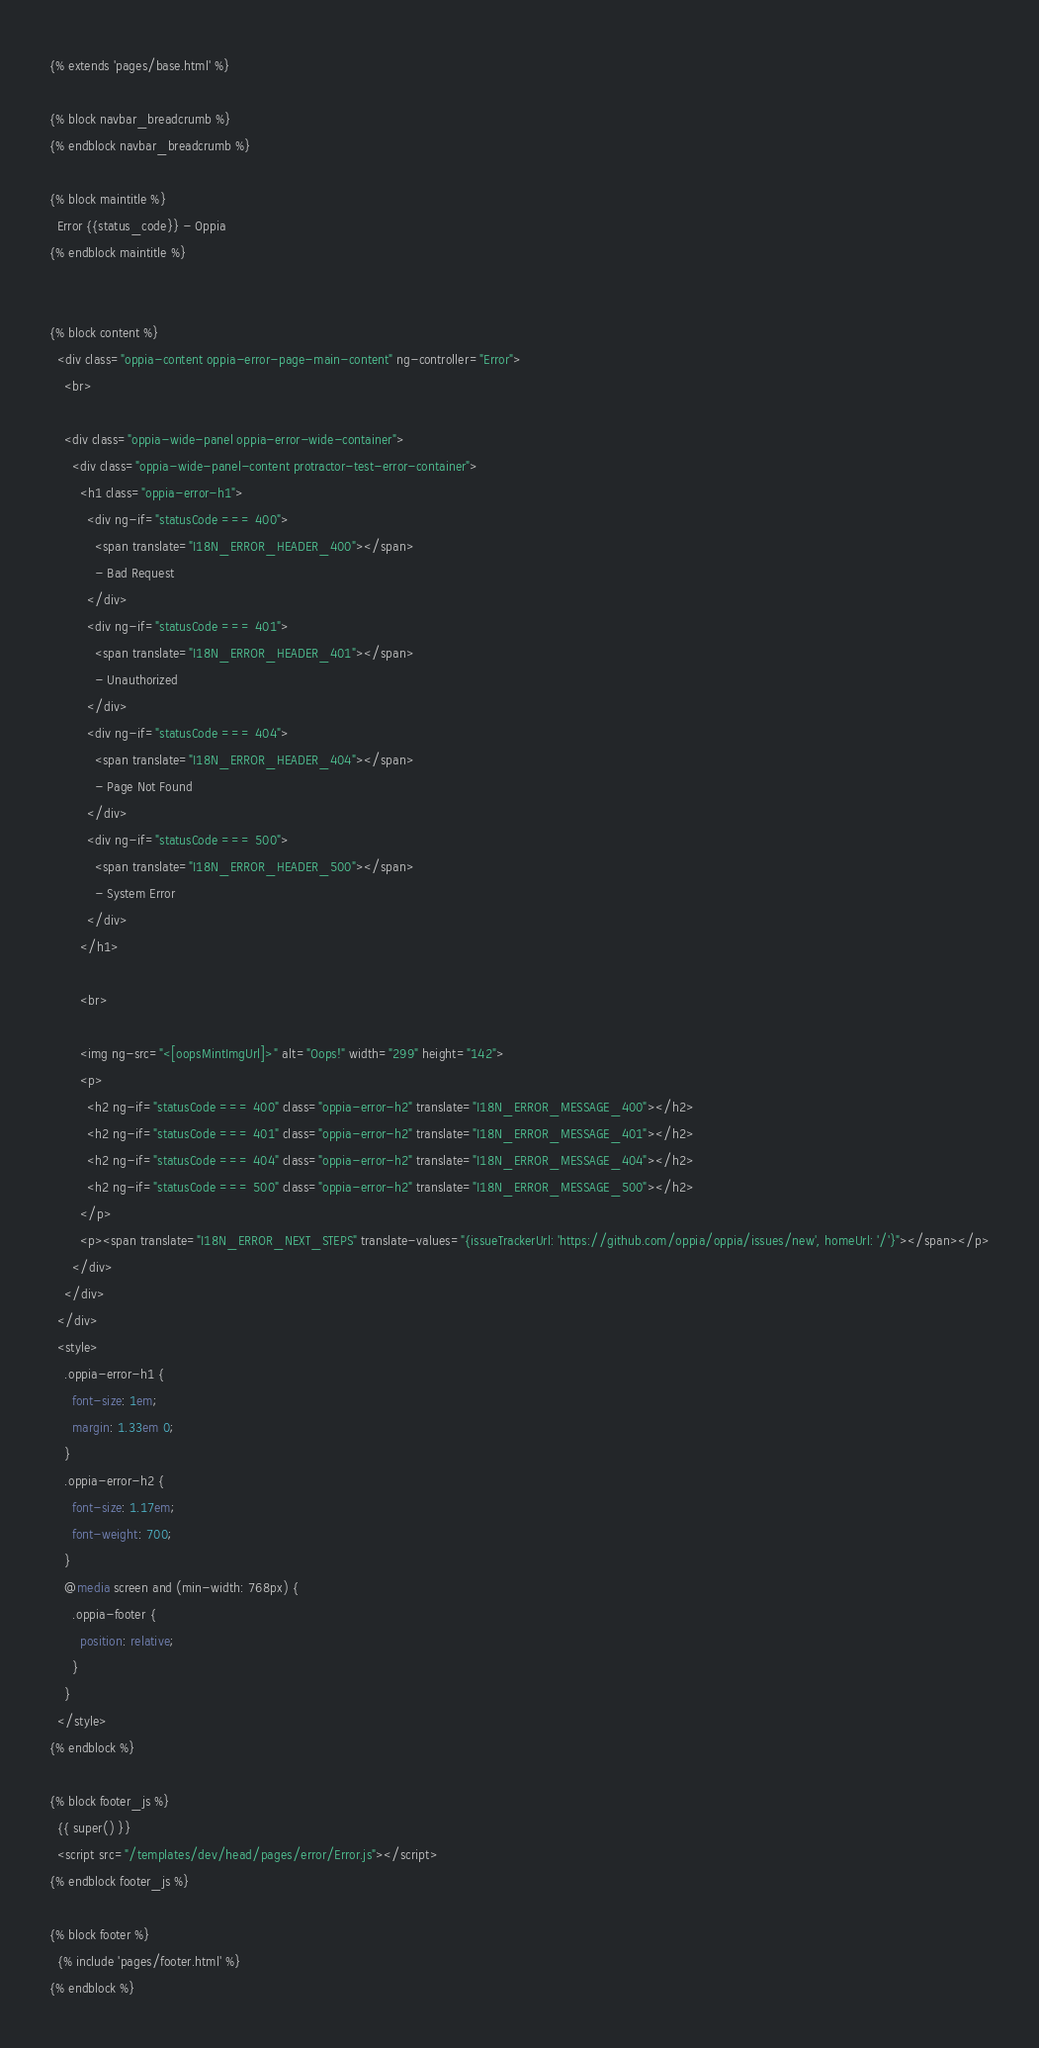<code> <loc_0><loc_0><loc_500><loc_500><_HTML_>{% extends 'pages/base.html' %}

{% block navbar_breadcrumb %}
{% endblock navbar_breadcrumb %}

{% block maintitle %}
  Error {{status_code}} - Oppia
{% endblock maintitle %}


{% block content %}
  <div class="oppia-content oppia-error-page-main-content" ng-controller="Error">
    <br>

    <div class="oppia-wide-panel oppia-error-wide-container">
      <div class="oppia-wide-panel-content protractor-test-error-container">
        <h1 class="oppia-error-h1">
          <div ng-if="statusCode === 400">
            <span translate="I18N_ERROR_HEADER_400"></span>
            - Bad Request
          </div>
          <div ng-if="statusCode === 401">
            <span translate="I18N_ERROR_HEADER_401"></span>
            - Unauthorized
          </div>
          <div ng-if="statusCode === 404">
            <span translate="I18N_ERROR_HEADER_404"></span>
            - Page Not Found
          </div>
          <div ng-if="statusCode === 500">
            <span translate="I18N_ERROR_HEADER_500"></span>
            - System Error
          </div>
        </h1>

        <br>

        <img ng-src="<[oopsMintImgUrl]>" alt="Oops!" width="299" height="142">
        <p>
          <h2 ng-if="statusCode === 400" class="oppia-error-h2" translate="I18N_ERROR_MESSAGE_400"></h2>
          <h2 ng-if="statusCode === 401" class="oppia-error-h2" translate="I18N_ERROR_MESSAGE_401"></h2>
          <h2 ng-if="statusCode === 404" class="oppia-error-h2" translate="I18N_ERROR_MESSAGE_404"></h2>
          <h2 ng-if="statusCode === 500" class="oppia-error-h2" translate="I18N_ERROR_MESSAGE_500"></h2>
        </p>
        <p><span translate="I18N_ERROR_NEXT_STEPS" translate-values="{issueTrackerUrl: 'https://github.com/oppia/oppia/issues/new', homeUrl: '/'}"></span></p>
      </div>
    </div>
  </div>
  <style>
    .oppia-error-h1 {
      font-size: 1em;
      margin: 1.33em 0;
    }
    .oppia-error-h2 {
      font-size: 1.17em;
      font-weight: 700;
    }
    @media screen and (min-width: 768px) {
      .oppia-footer {
        position: relative;
      }
    }
  </style>
{% endblock %}

{% block footer_js %}
  {{ super() }}
  <script src="/templates/dev/head/pages/error/Error.js"></script>
{% endblock footer_js %}

{% block footer %}
  {% include 'pages/footer.html' %}
{% endblock %}
</code> 